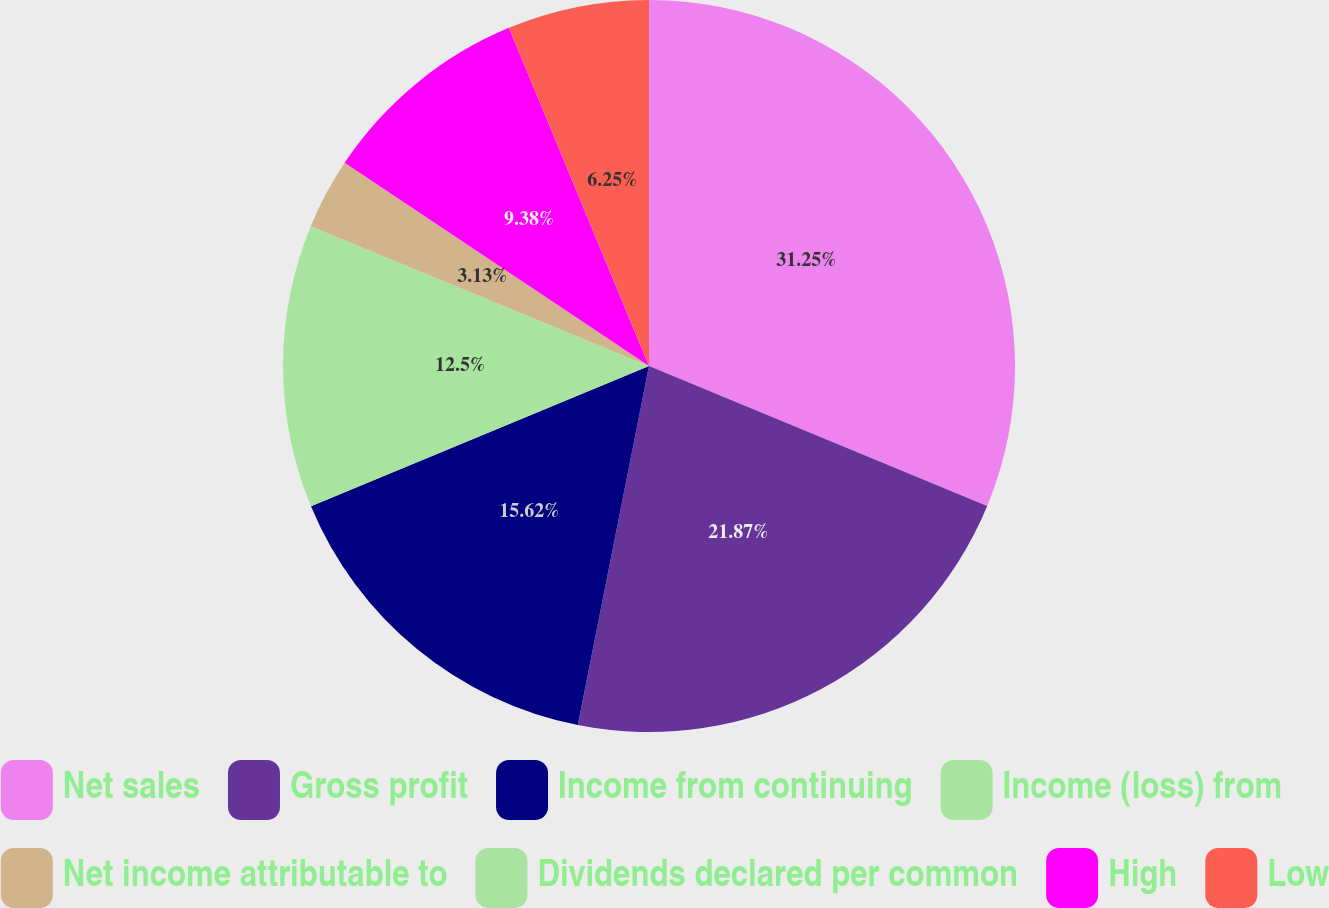Convert chart to OTSL. <chart><loc_0><loc_0><loc_500><loc_500><pie_chart><fcel>Net sales<fcel>Gross profit<fcel>Income from continuing<fcel>Income (loss) from<fcel>Net income attributable to<fcel>Dividends declared per common<fcel>High<fcel>Low<nl><fcel>31.24%<fcel>21.87%<fcel>15.62%<fcel>12.5%<fcel>3.13%<fcel>0.0%<fcel>9.38%<fcel>6.25%<nl></chart> 